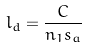Convert formula to latex. <formula><loc_0><loc_0><loc_500><loc_500>l _ { d } = \frac { C } { n _ { 1 } s _ { a } }</formula> 